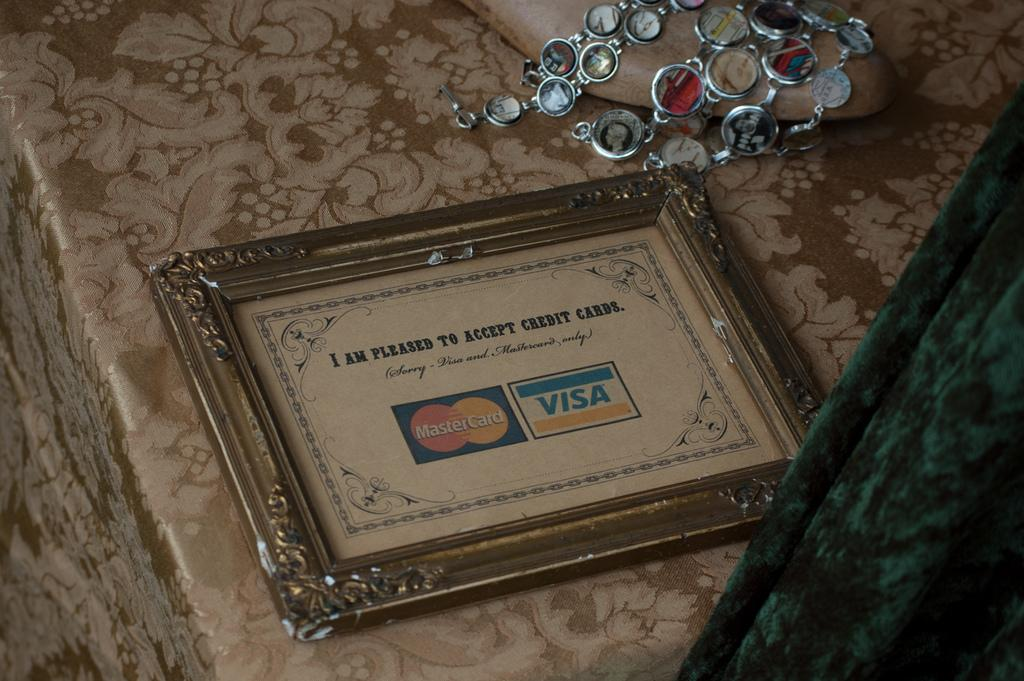<image>
Summarize the visual content of the image. Framed picture showing a Mastercard logo and Visa logo. 